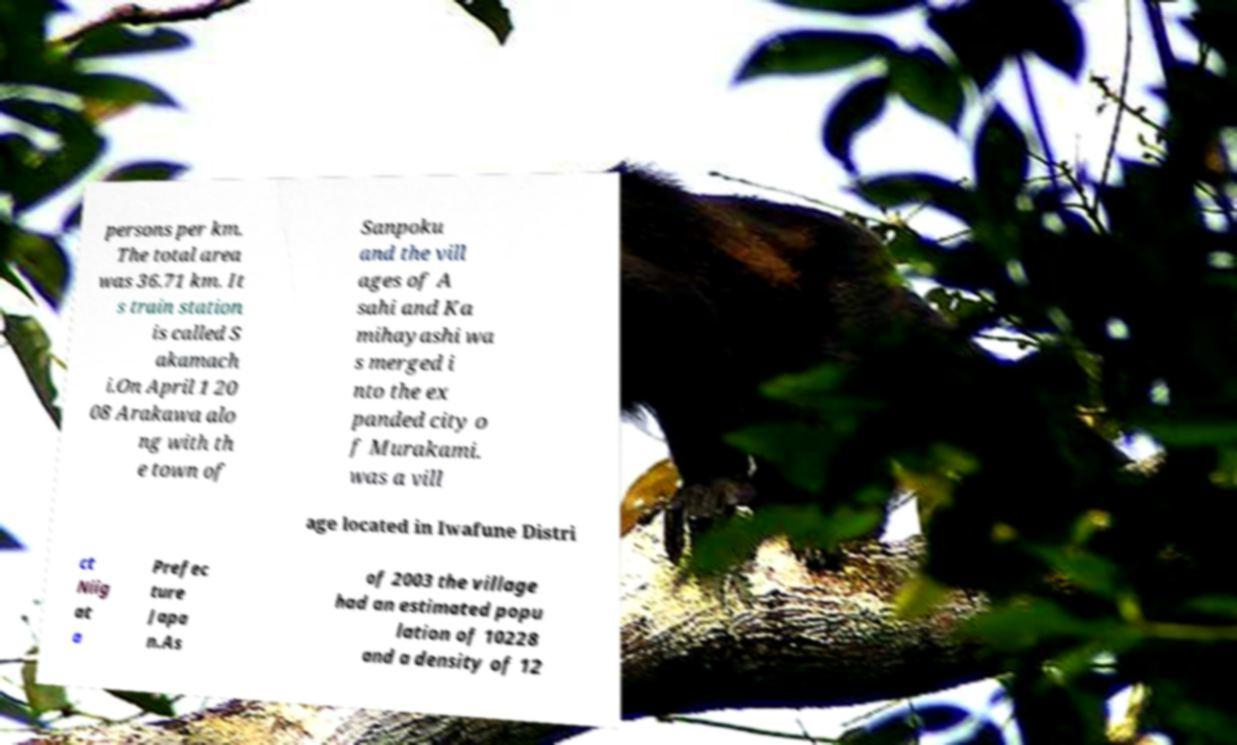Could you extract and type out the text from this image? persons per km. The total area was 36.71 km. It s train station is called S akamach i.On April 1 20 08 Arakawa alo ng with th e town of Sanpoku and the vill ages of A sahi and Ka mihayashi wa s merged i nto the ex panded city o f Murakami. was a vill age located in Iwafune Distri ct Niig at a Prefec ture Japa n.As of 2003 the village had an estimated popu lation of 10228 and a density of 12 